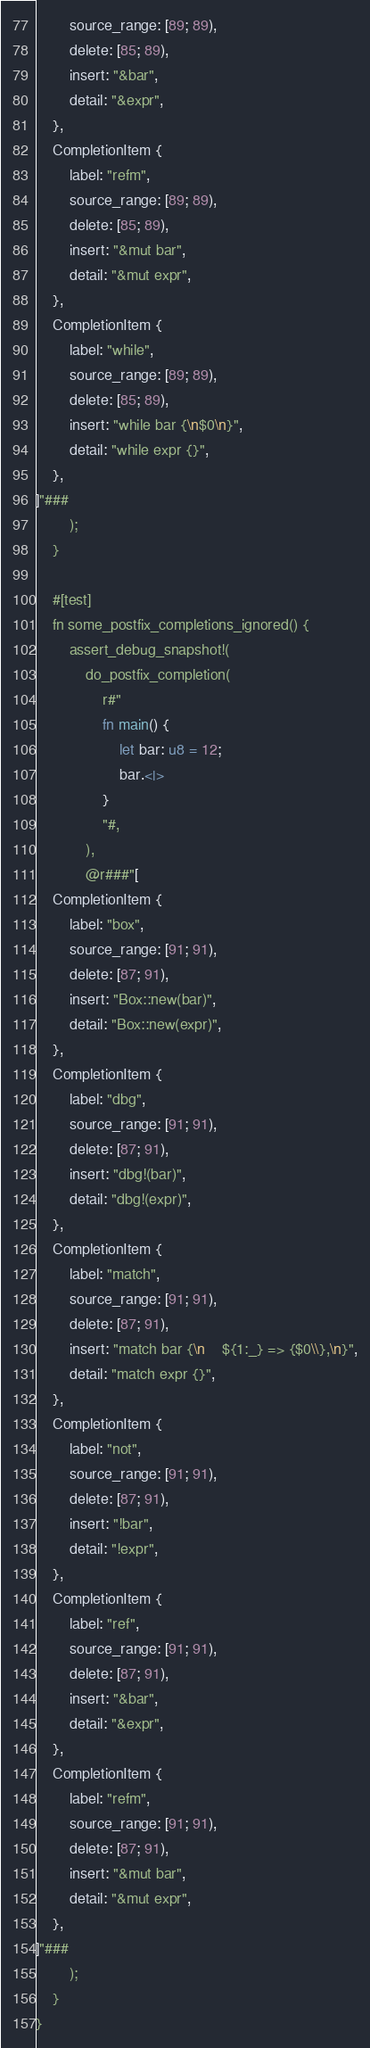Convert code to text. <code><loc_0><loc_0><loc_500><loc_500><_Rust_>        source_range: [89; 89),
        delete: [85; 89),
        insert: "&bar",
        detail: "&expr",
    },
    CompletionItem {
        label: "refm",
        source_range: [89; 89),
        delete: [85; 89),
        insert: "&mut bar",
        detail: "&mut expr",
    },
    CompletionItem {
        label: "while",
        source_range: [89; 89),
        delete: [85; 89),
        insert: "while bar {\n$0\n}",
        detail: "while expr {}",
    },
]"###
        );
    }

    #[test]
    fn some_postfix_completions_ignored() {
        assert_debug_snapshot!(
            do_postfix_completion(
                r#"
                fn main() {
                    let bar: u8 = 12;
                    bar.<|>
                }
                "#,
            ),
            @r###"[
    CompletionItem {
        label: "box",
        source_range: [91; 91),
        delete: [87; 91),
        insert: "Box::new(bar)",
        detail: "Box::new(expr)",
    },
    CompletionItem {
        label: "dbg",
        source_range: [91; 91),
        delete: [87; 91),
        insert: "dbg!(bar)",
        detail: "dbg!(expr)",
    },
    CompletionItem {
        label: "match",
        source_range: [91; 91),
        delete: [87; 91),
        insert: "match bar {\n    ${1:_} => {$0\\},\n}",
        detail: "match expr {}",
    },
    CompletionItem {
        label: "not",
        source_range: [91; 91),
        delete: [87; 91),
        insert: "!bar",
        detail: "!expr",
    },
    CompletionItem {
        label: "ref",
        source_range: [91; 91),
        delete: [87; 91),
        insert: "&bar",
        detail: "&expr",
    },
    CompletionItem {
        label: "refm",
        source_range: [91; 91),
        delete: [87; 91),
        insert: "&mut bar",
        detail: "&mut expr",
    },
]"###
        );
    }
}
</code> 